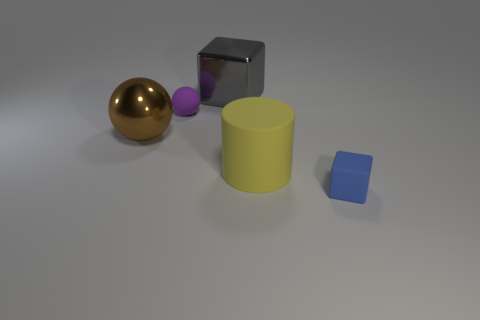Is the small object that is left of the blue object made of the same material as the cube on the left side of the large cylinder?
Offer a terse response. No. What is the material of the large yellow object?
Offer a very short reply. Rubber. What number of other objects are there of the same color as the big shiny sphere?
Your answer should be compact. 0. Does the tiny cube have the same color as the cylinder?
Your answer should be compact. No. What number of yellow matte things are there?
Your answer should be very brief. 1. What is the material of the block that is right of the big thing to the right of the gray block?
Offer a very short reply. Rubber. There is a object that is the same size as the purple ball; what material is it?
Make the answer very short. Rubber. There is a rubber object behind the rubber cylinder; is its size the same as the small blue matte block?
Your response must be concise. Yes. Does the metal object that is in front of the gray thing have the same shape as the purple rubber thing?
Offer a terse response. Yes. What number of things are either small red things or tiny things to the right of the matte cylinder?
Your answer should be very brief. 1. 